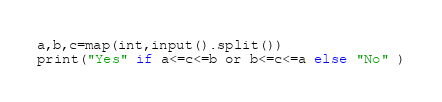<code> <loc_0><loc_0><loc_500><loc_500><_Python_>a,b,c=map(int,input().split()) 
print("Yes" if a<=c<=b or b<=c<=a else "No" )

</code> 